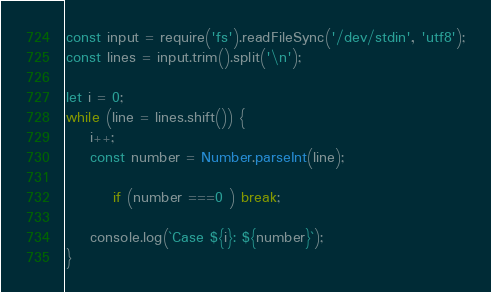<code> <loc_0><loc_0><loc_500><loc_500><_JavaScript_>const input = require('fs').readFileSync('/dev/stdin', 'utf8');
const lines = input.trim().split('\n');

let i = 0;
while (line = lines.shift()) {
	i++;
	const number = Number.parseInt(line);

        if (number ===0 ) break;

	console.log(`Case ${i}: ${number}`);
}

</code> 